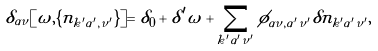Convert formula to latex. <formula><loc_0><loc_0><loc_500><loc_500>\delta _ { \alpha \nu } [ \omega , \{ n _ { k ^ { \prime } \alpha ^ { \prime } , \nu ^ { \prime } } \} ] = \delta _ { 0 } + \delta ^ { \prime } \omega + \sum _ { k ^ { \prime } \alpha ^ { \prime } \nu ^ { \prime } } \phi _ { \alpha \nu , \alpha ^ { \prime } \nu ^ { \prime } } \delta n _ { k ^ { \prime } \alpha ^ { \prime } \nu ^ { \prime } } ,</formula> 